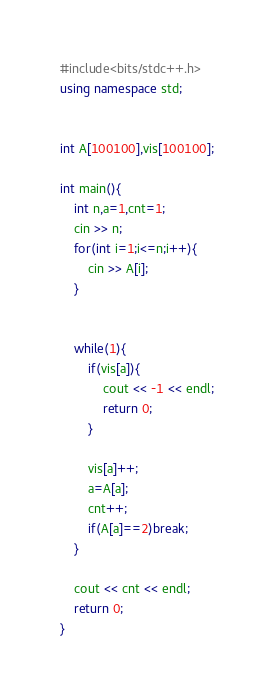<code> <loc_0><loc_0><loc_500><loc_500><_C++_>#include<bits/stdc++.h>
using namespace std;


int A[100100],vis[100100];

int main(){
	int n,a=1,cnt=1;
	cin >> n;
	for(int i=1;i<=n;i++){
		cin >> A[i];
	}
	
	
	while(1){
		if(vis[a]){
			cout << -1 << endl;
			return 0;
		}
		
		vis[a]++;
		a=A[a];
		cnt++;
		if(A[a]==2)break;
	}
	
	cout << cnt << endl;
	return 0;
}</code> 